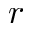Convert formula to latex. <formula><loc_0><loc_0><loc_500><loc_500>r</formula> 